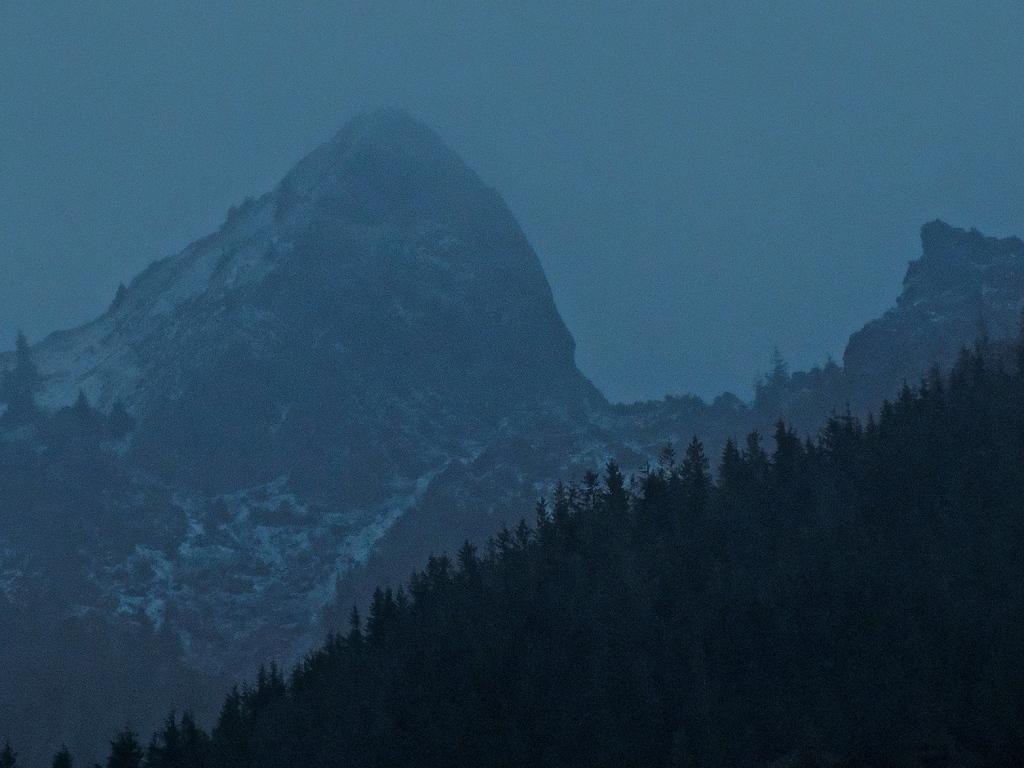What type of natural formation can be seen in the image? There are mountains in the image. What type of vegetation is present in the image? There are trees in the image. What is the weather like in the image? There is snow visible in the image, indicating cold weather. What is visible at the top of the image? The sky is visible at the top of the image. What is the price of the straw in the image? There is no straw present in the image, so it is not possible to determine its price. What type of lunch is being served in the image? There is no lunch or any food items present in the image; it features mountains, trees, snow, and the sky. 